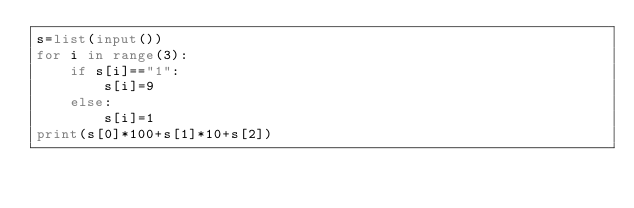<code> <loc_0><loc_0><loc_500><loc_500><_Python_>s=list(input())
for i in range(3):
    if s[i]=="1":
        s[i]=9
    else:
        s[i]=1
print(s[0]*100+s[1]*10+s[2])</code> 